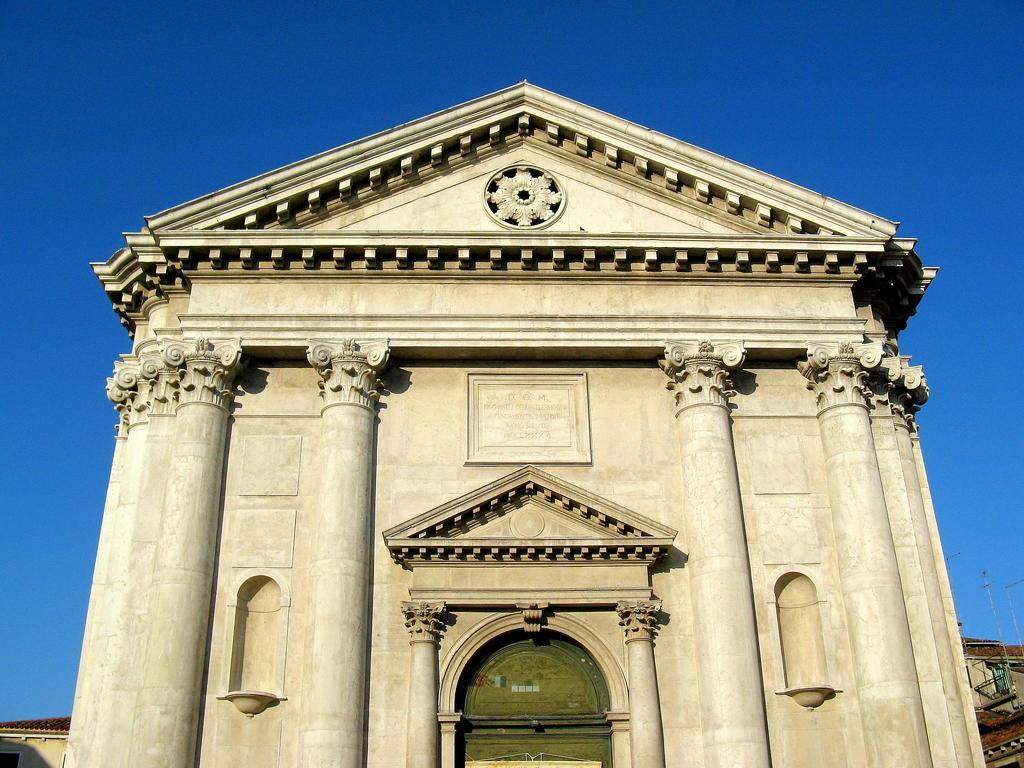What is the main structure in the image? There is a building in the image. What color is the entrance of the building? The entrance of the building is green. What can be seen in the background of the image? There are other buildings and antennas visible in the background of the image. What is visible in the sky in the image? The sky is visible in the background of the image. Where is the doll hidden in the image? There is no doll present in the image. What type of glove is being used by the building in the image? Buildings do not have the ability to use gloves, as they are inanimate structures. 